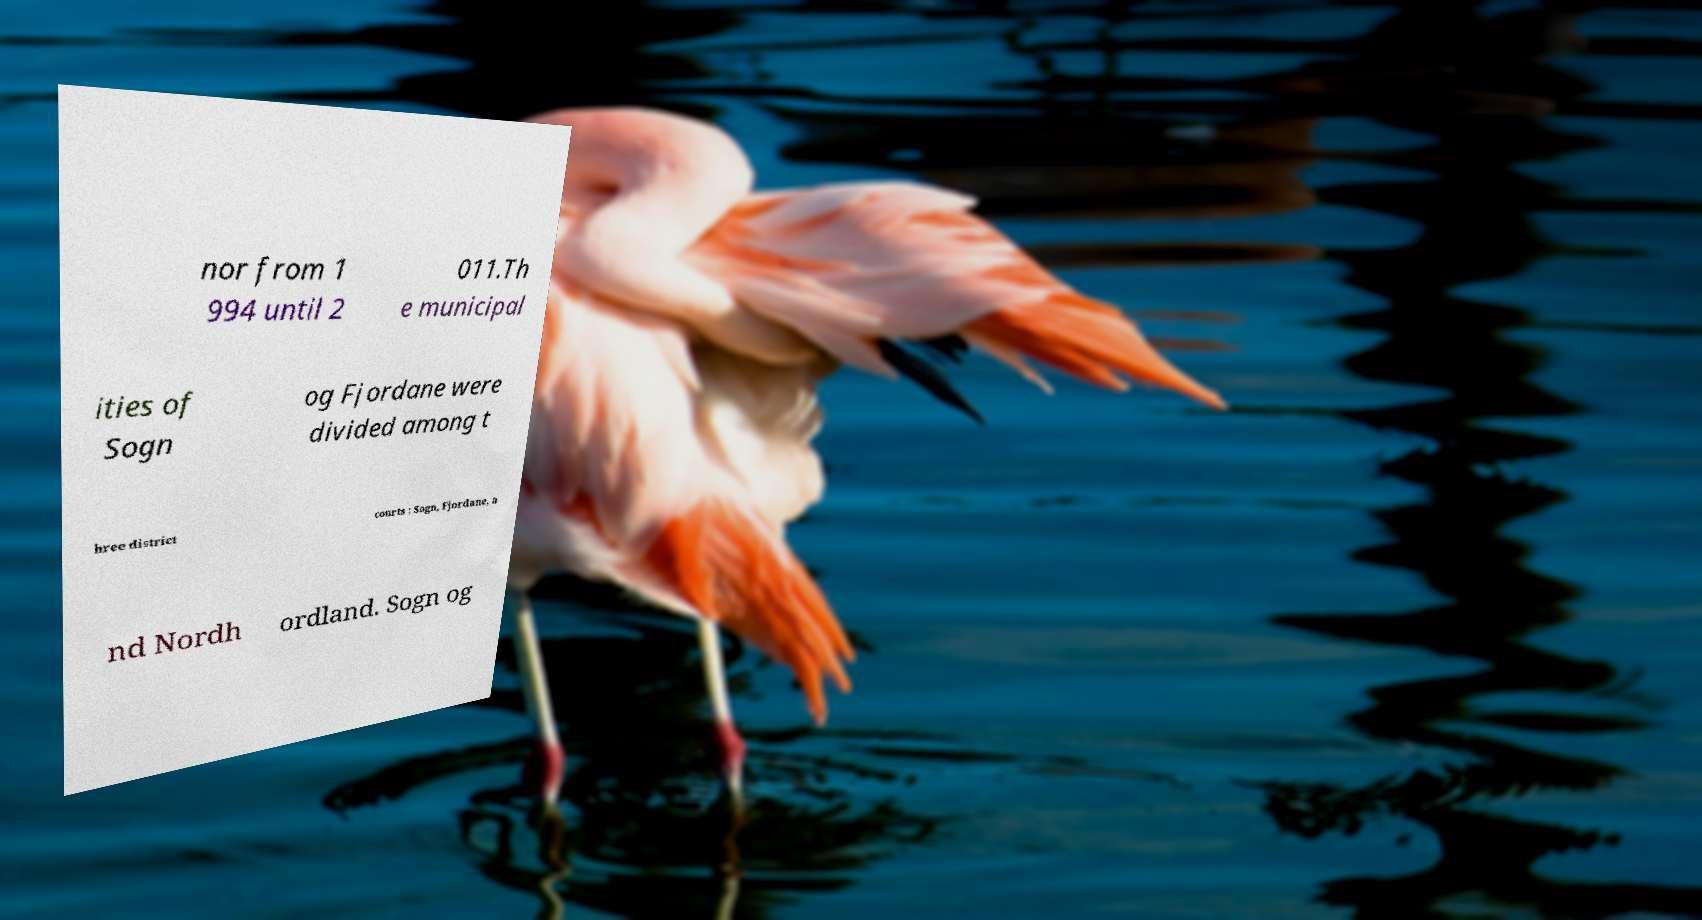Could you extract and type out the text from this image? nor from 1 994 until 2 011.Th e municipal ities of Sogn og Fjordane were divided among t hree district courts : Sogn, Fjordane, a nd Nordh ordland. Sogn og 